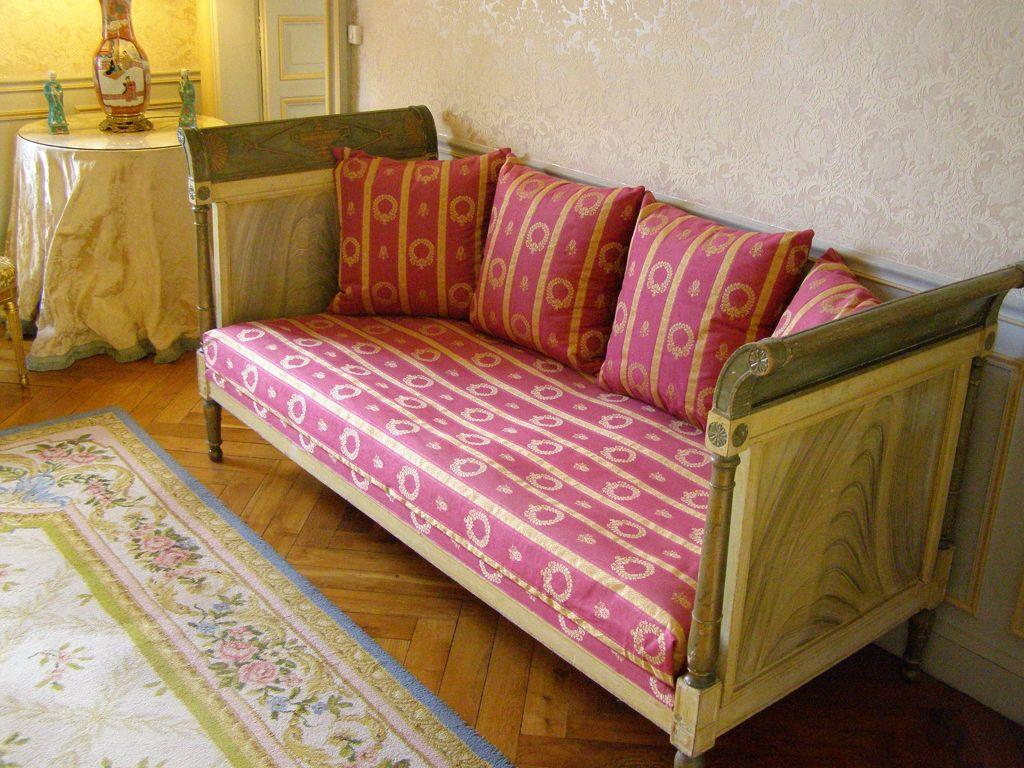What type of furniture is in the image? There is a couch in the image. What color are the pillows on the couch? The pillows on the couch are pink-colored. What can be seen on a table in the background of the image? There are glass pots on a table in the background. What color is the wall in the image? The wall is white in color. What type of gold ornament is hanging from the ceiling in the image? There is no gold ornament hanging from the ceiling in the image. What degree of education does the person in the image have? There is no person present in the image, so their degree of education cannot be determined. 